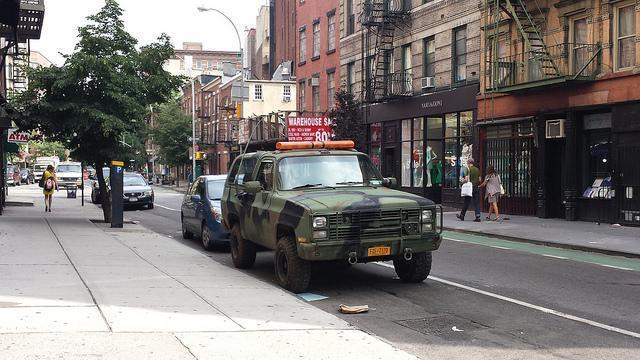How many cars are there?
Give a very brief answer. 1. 